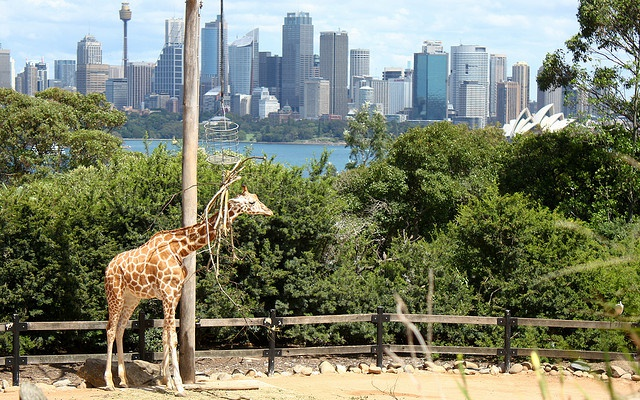Describe the objects in this image and their specific colors. I can see a giraffe in lightblue, ivory, tan, and brown tones in this image. 